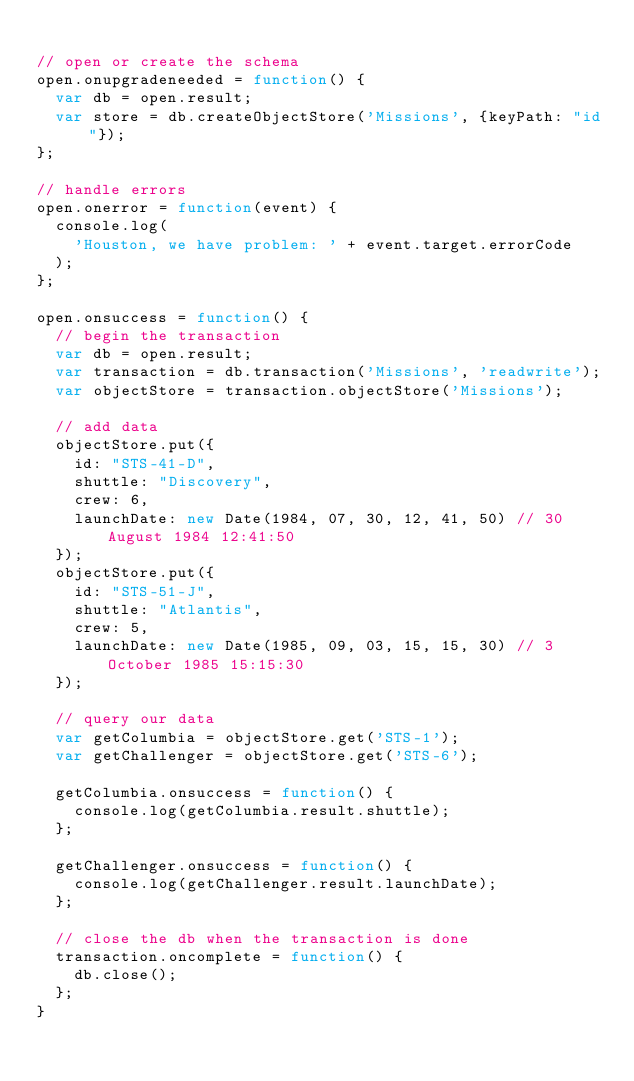<code> <loc_0><loc_0><loc_500><loc_500><_JavaScript_>
// open or create the schema
open.onupgradeneeded = function() {
  var db = open.result;
  var store = db.createObjectStore('Missions', {keyPath: "id"});
};

// handle errors
open.onerror = function(event) {
  console.log(
    'Houston, we have problem: ' + event.target.errorCode
  );
};

open.onsuccess = function() {
  // begin the transaction
  var db = open.result;
  var transaction = db.transaction('Missions', 'readwrite');
  var objectStore = transaction.objectStore('Missions');

  // add data
  objectStore.put({
    id: "STS-41-D",
    shuttle: "Discovery",
    crew: 6,
    launchDate: new Date(1984, 07, 30, 12, 41, 50) // 30 August 1984 12:41:50
  });
  objectStore.put({
    id: "STS-51-J",
    shuttle: "Atlantis",
    crew: 5,
    launchDate: new Date(1985, 09, 03, 15, 15, 30) // 3 October 1985 15:15:30
  });

  // query our data
  var getColumbia = objectStore.get('STS-1');
  var getChallenger = objectStore.get('STS-6');

  getColumbia.onsuccess = function() {
    console.log(getColumbia.result.shuttle);
  };

  getChallenger.onsuccess = function() {
    console.log(getChallenger.result.launchDate);
  };

  // close the db when the transaction is done
  transaction.oncomplete = function() {
    db.close();
  };
}
</code> 